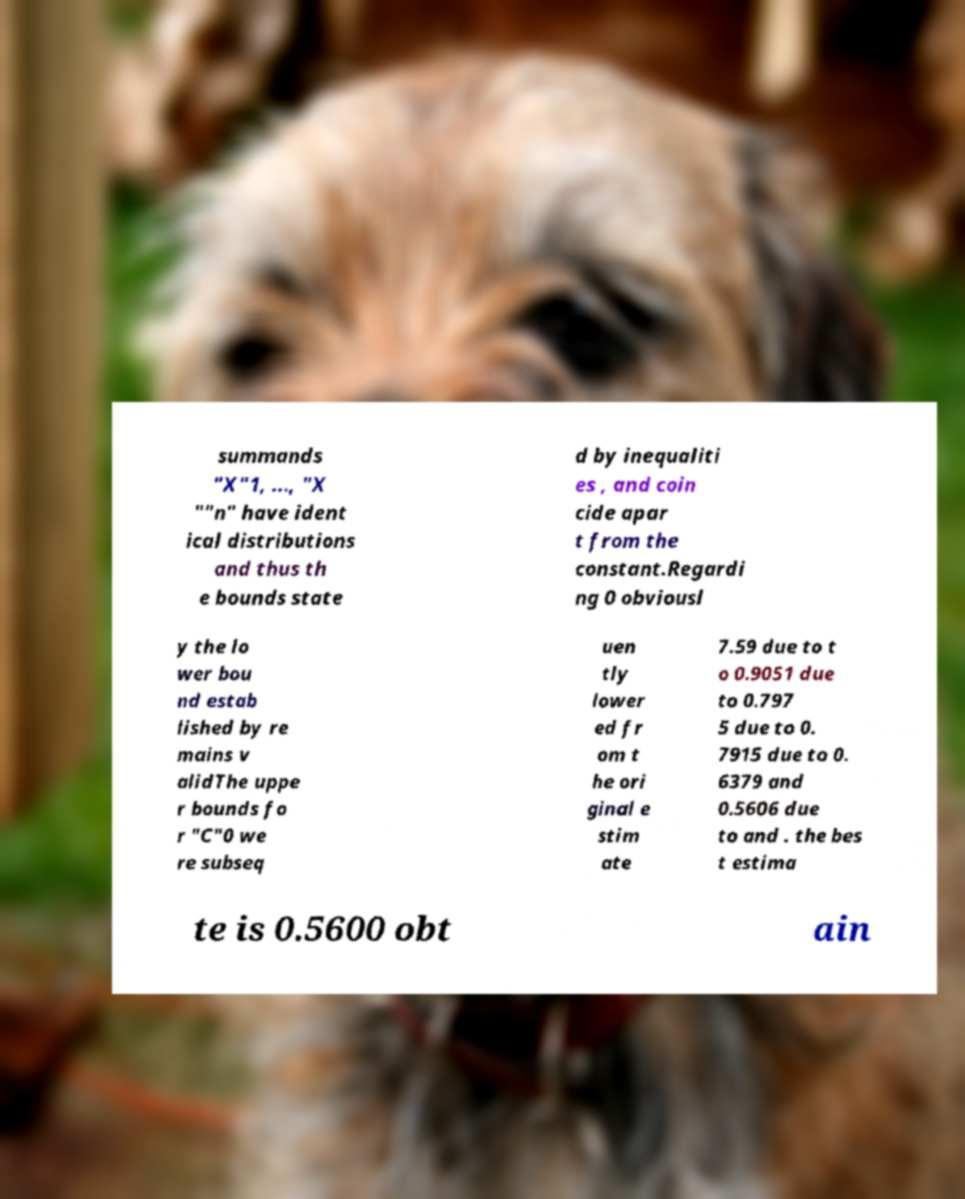Please identify and transcribe the text found in this image. summands "X"1, ..., "X ""n" have ident ical distributions and thus th e bounds state d by inequaliti es , and coin cide apar t from the constant.Regardi ng 0 obviousl y the lo wer bou nd estab lished by re mains v alidThe uppe r bounds fo r "C"0 we re subseq uen tly lower ed fr om t he ori ginal e stim ate 7.59 due to t o 0.9051 due to 0.797 5 due to 0. 7915 due to 0. 6379 and 0.5606 due to and . the bes t estima te is 0.5600 obt ain 